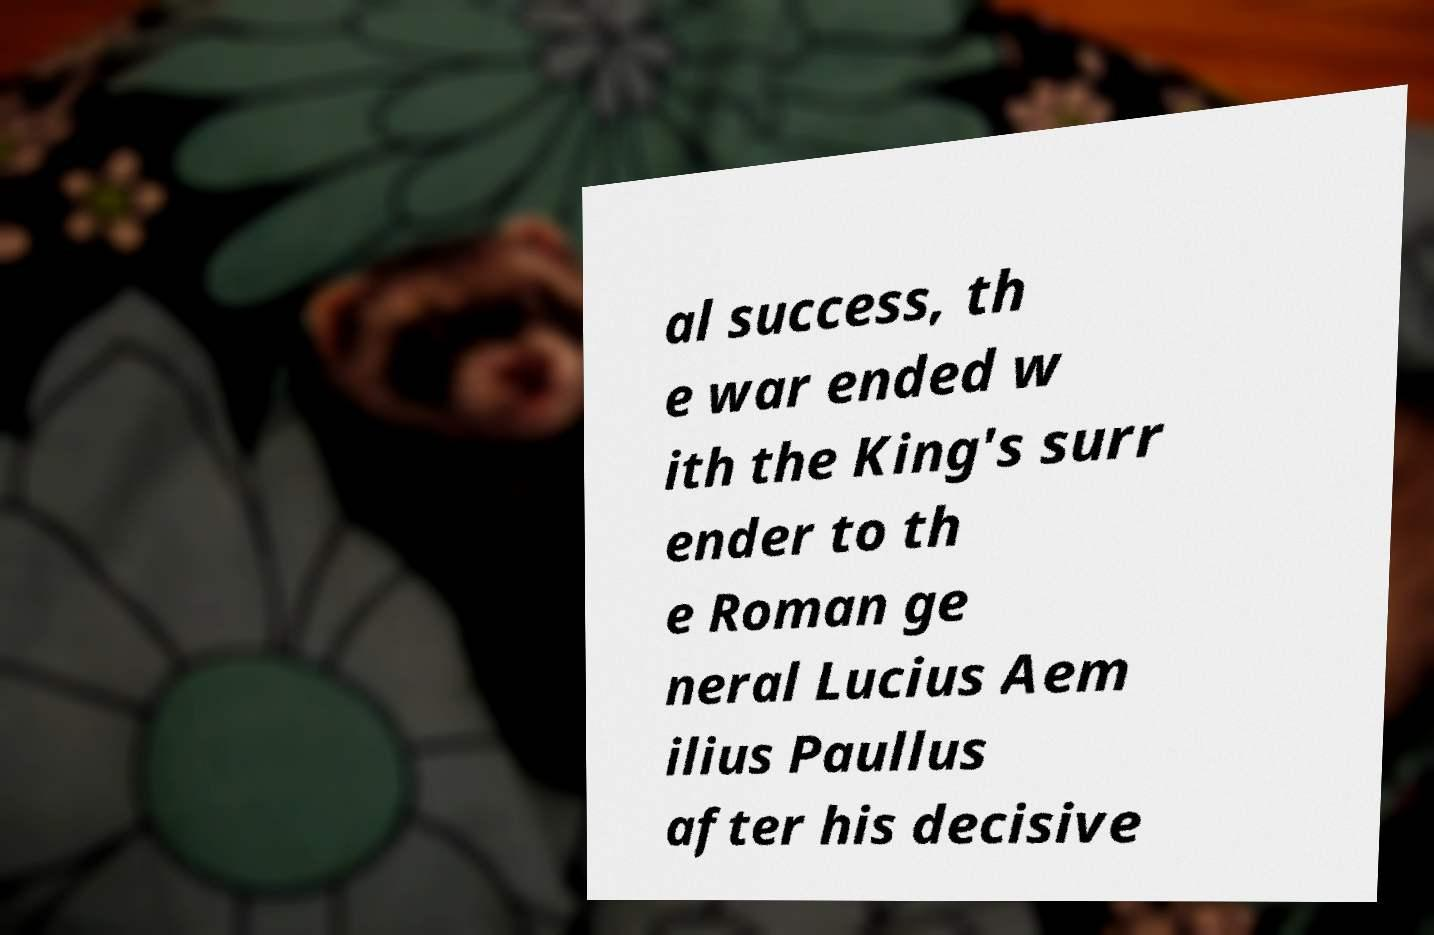Could you extract and type out the text from this image? al success, th e war ended w ith the King's surr ender to th e Roman ge neral Lucius Aem ilius Paullus after his decisive 